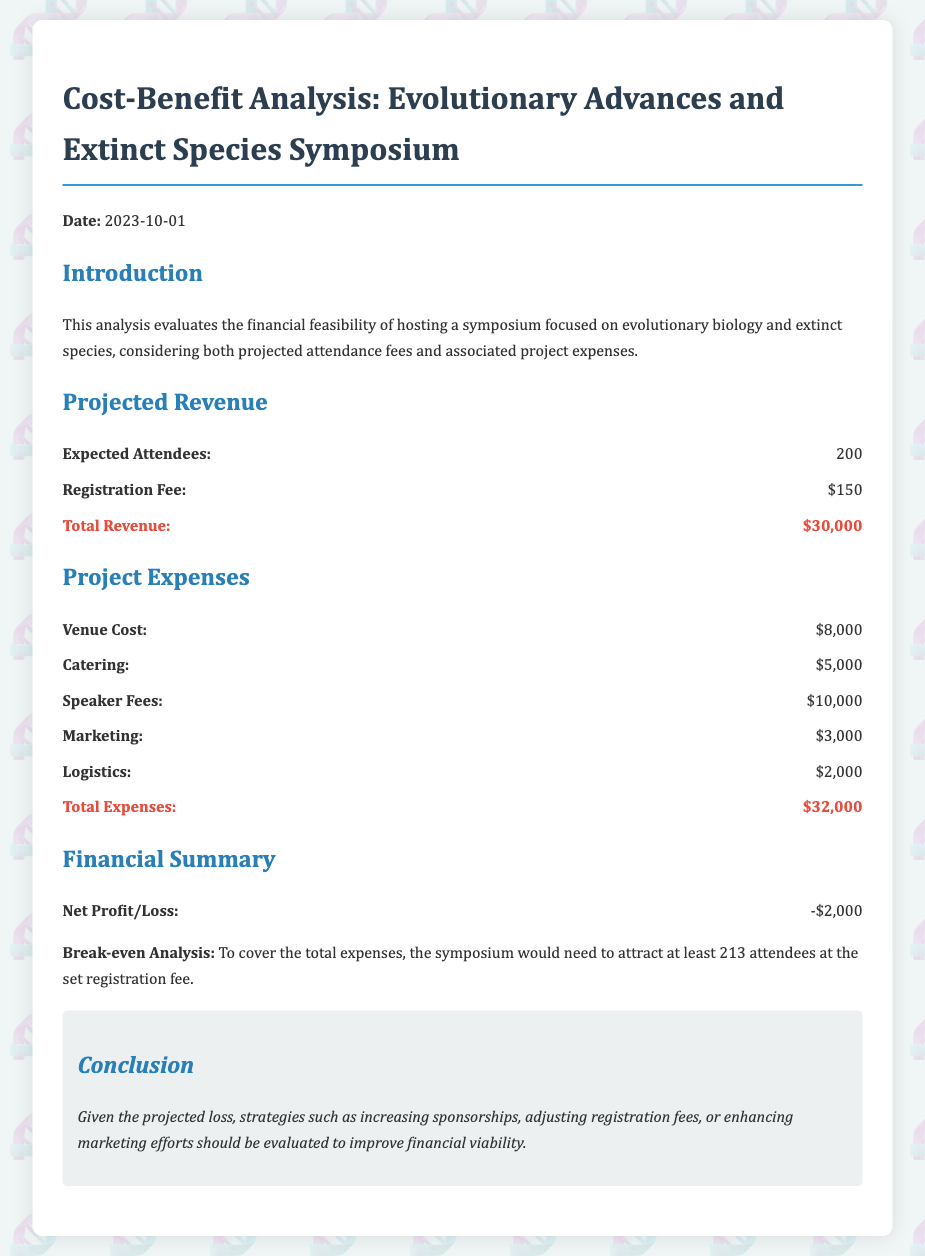what is the date of the symposium? The date of the symposium is stated in the document.
Answer: 2023-10-01 how many expected attendees are projected? The expected attendees are detailed in the projected revenue section of the document.
Answer: 200 what is the registration fee? The registration fee is provided in the projected revenue section of the document.
Answer: $150 what is the total expense amount? The total expenses are summarized in the project expenses section of the document.
Answer: $32,000 what is the net profit/loss indicated in the financial summary? The net profit/loss is stated in the financial summary section of the document.
Answer: -$2,000 how many attendees are needed to break even? The break-even analysis specifies the required number of attendees to cover expenses.
Answer: 213 what was the venue cost? Venue cost is itemized in the project expenses section of the document.
Answer: $8,000 which strategy is suggested in the conclusion to improve financial viability? The conclusion provides various strategies to improve financial viability.
Answer: Increasing sponsorships 